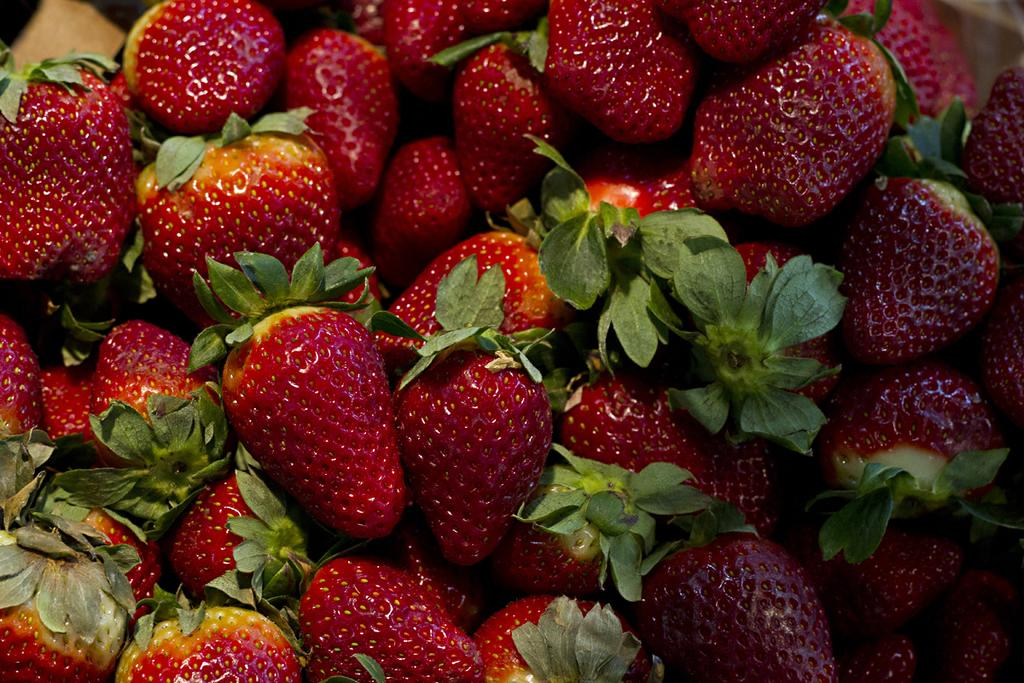What type of fruit is present in the image? There are strawberries in the image. What type of hose is used to water the strawberries in the image? There is no hose present in the image, as it only features strawberries. 